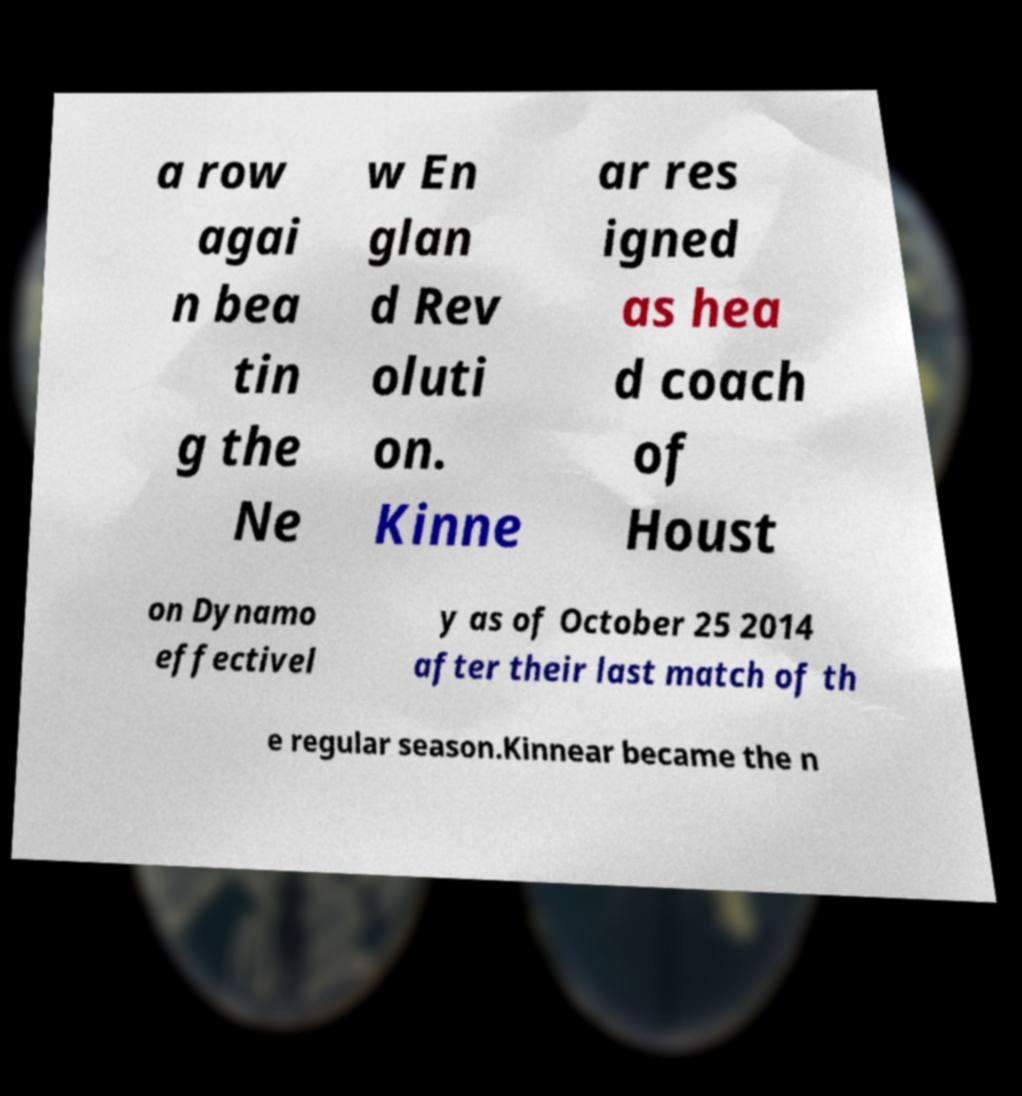Could you extract and type out the text from this image? a row agai n bea tin g the Ne w En glan d Rev oluti on. Kinne ar res igned as hea d coach of Houst on Dynamo effectivel y as of October 25 2014 after their last match of th e regular season.Kinnear became the n 